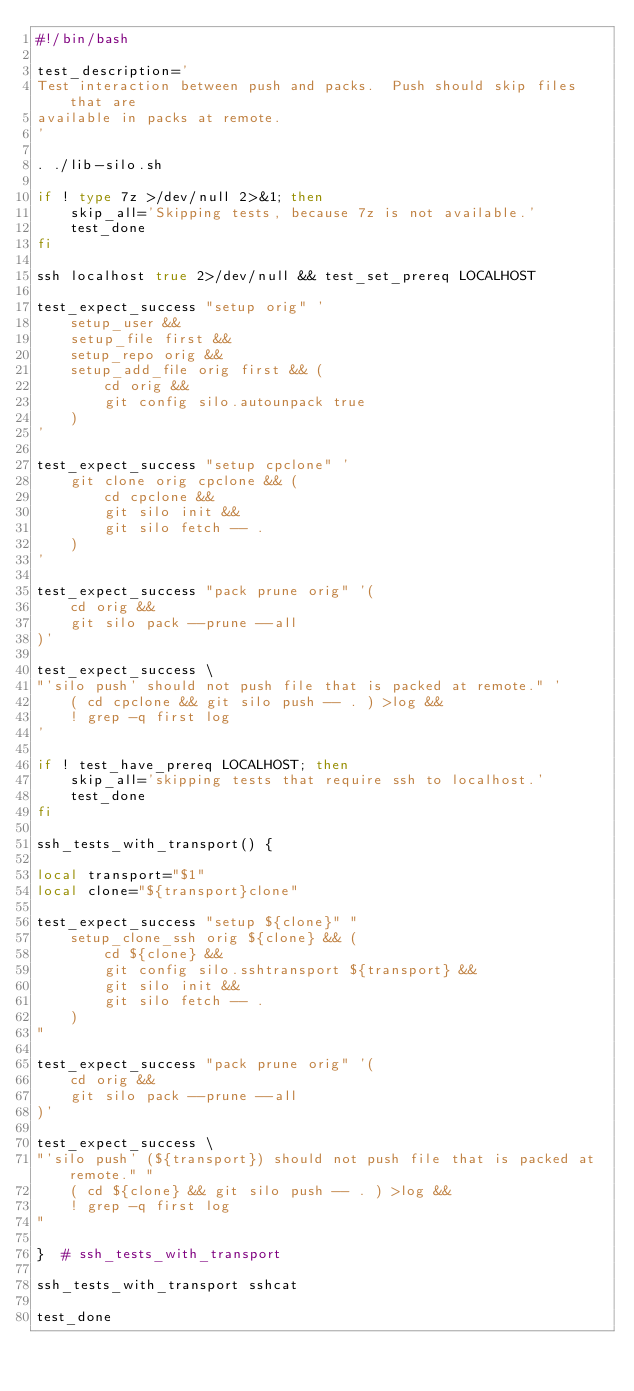<code> <loc_0><loc_0><loc_500><loc_500><_Bash_>#!/bin/bash

test_description='
Test interaction between push and packs.  Push should skip files that are
available in packs at remote.
'

. ./lib-silo.sh

if ! type 7z >/dev/null 2>&1; then
    skip_all='Skipping tests, because 7z is not available.'
    test_done
fi

ssh localhost true 2>/dev/null && test_set_prereq LOCALHOST

test_expect_success "setup orig" '
    setup_user &&
    setup_file first &&
    setup_repo orig &&
    setup_add_file orig first && (
        cd orig &&
        git config silo.autounpack true
    )
'

test_expect_success "setup cpclone" '
    git clone orig cpclone && (
        cd cpclone &&
        git silo init &&
        git silo fetch -- .
    )
'

test_expect_success "pack prune orig" '(
    cd orig &&
    git silo pack --prune --all
)'

test_expect_success \
"'silo push' should not push file that is packed at remote." '
    ( cd cpclone && git silo push -- . ) >log &&
    ! grep -q first log
'

if ! test_have_prereq LOCALHOST; then
    skip_all='skipping tests that require ssh to localhost.'
    test_done
fi

ssh_tests_with_transport() {

local transport="$1"
local clone="${transport}clone"

test_expect_success "setup ${clone}" "
    setup_clone_ssh orig ${clone} && (
        cd ${clone} &&
        git config silo.sshtransport ${transport} &&
        git silo init &&
        git silo fetch -- .
    )
"

test_expect_success "pack prune orig" '(
    cd orig &&
    git silo pack --prune --all
)'

test_expect_success \
"'silo push' (${transport}) should not push file that is packed at remote." "
    ( cd ${clone} && git silo push -- . ) >log &&
    ! grep -q first log
"

}  # ssh_tests_with_transport

ssh_tests_with_transport sshcat

test_done
</code> 